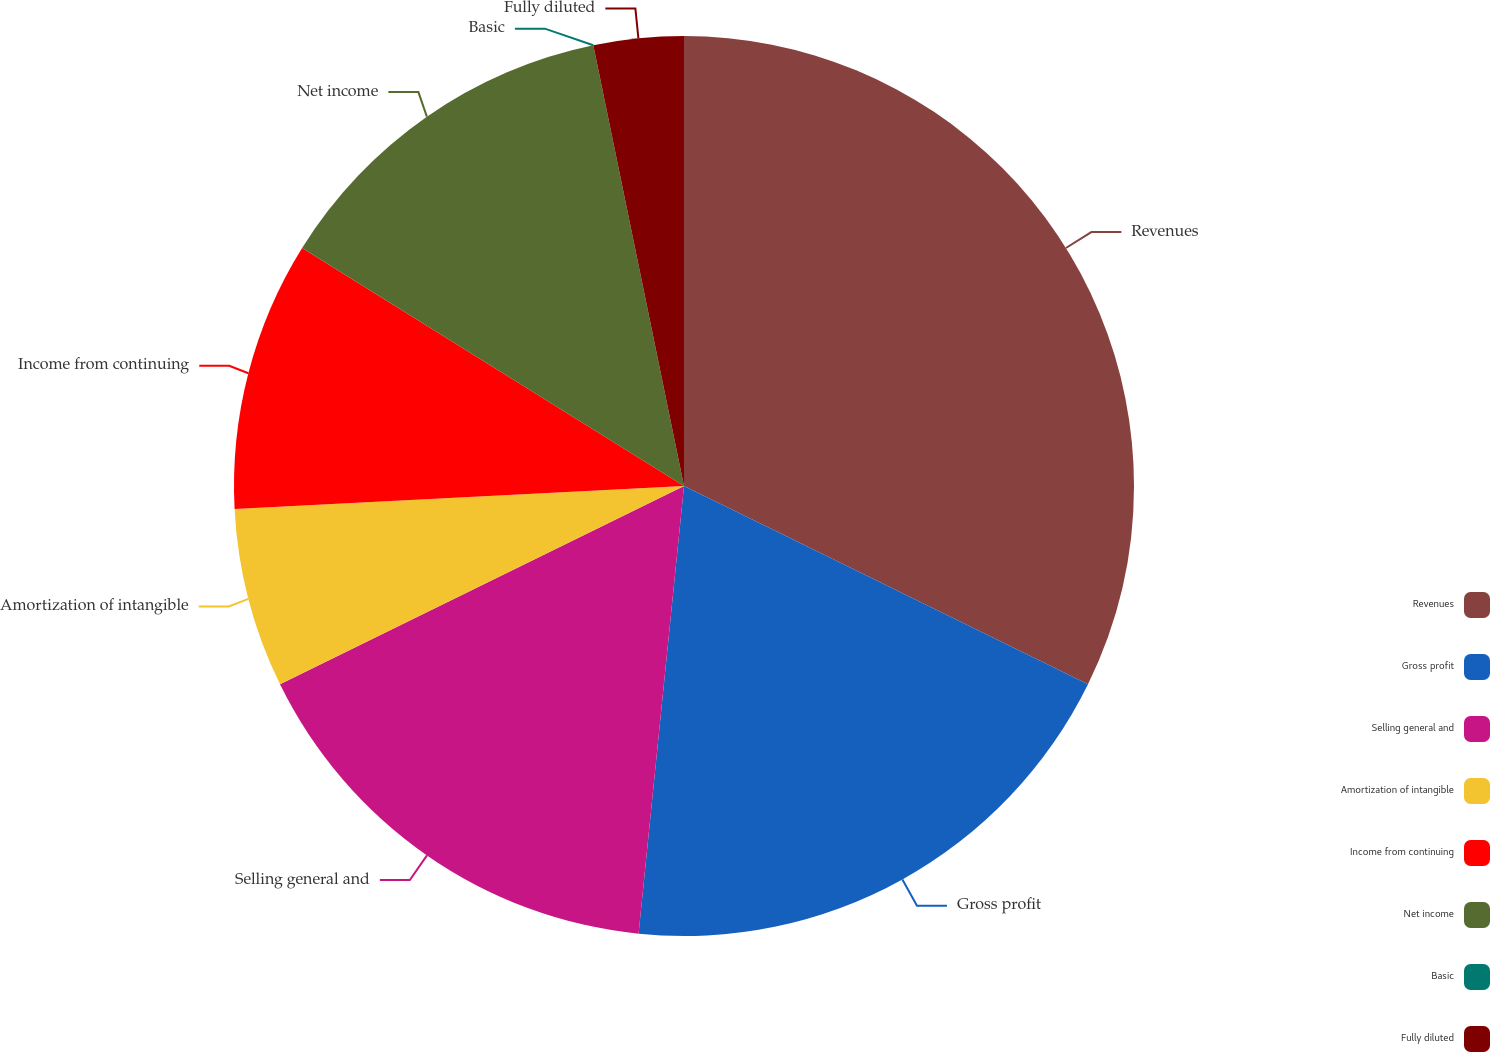<chart> <loc_0><loc_0><loc_500><loc_500><pie_chart><fcel>Revenues<fcel>Gross profit<fcel>Selling general and<fcel>Amortization of intangible<fcel>Income from continuing<fcel>Net income<fcel>Basic<fcel>Fully diluted<nl><fcel>32.26%<fcel>19.35%<fcel>16.13%<fcel>6.45%<fcel>9.68%<fcel>12.9%<fcel>0.0%<fcel>3.23%<nl></chart> 